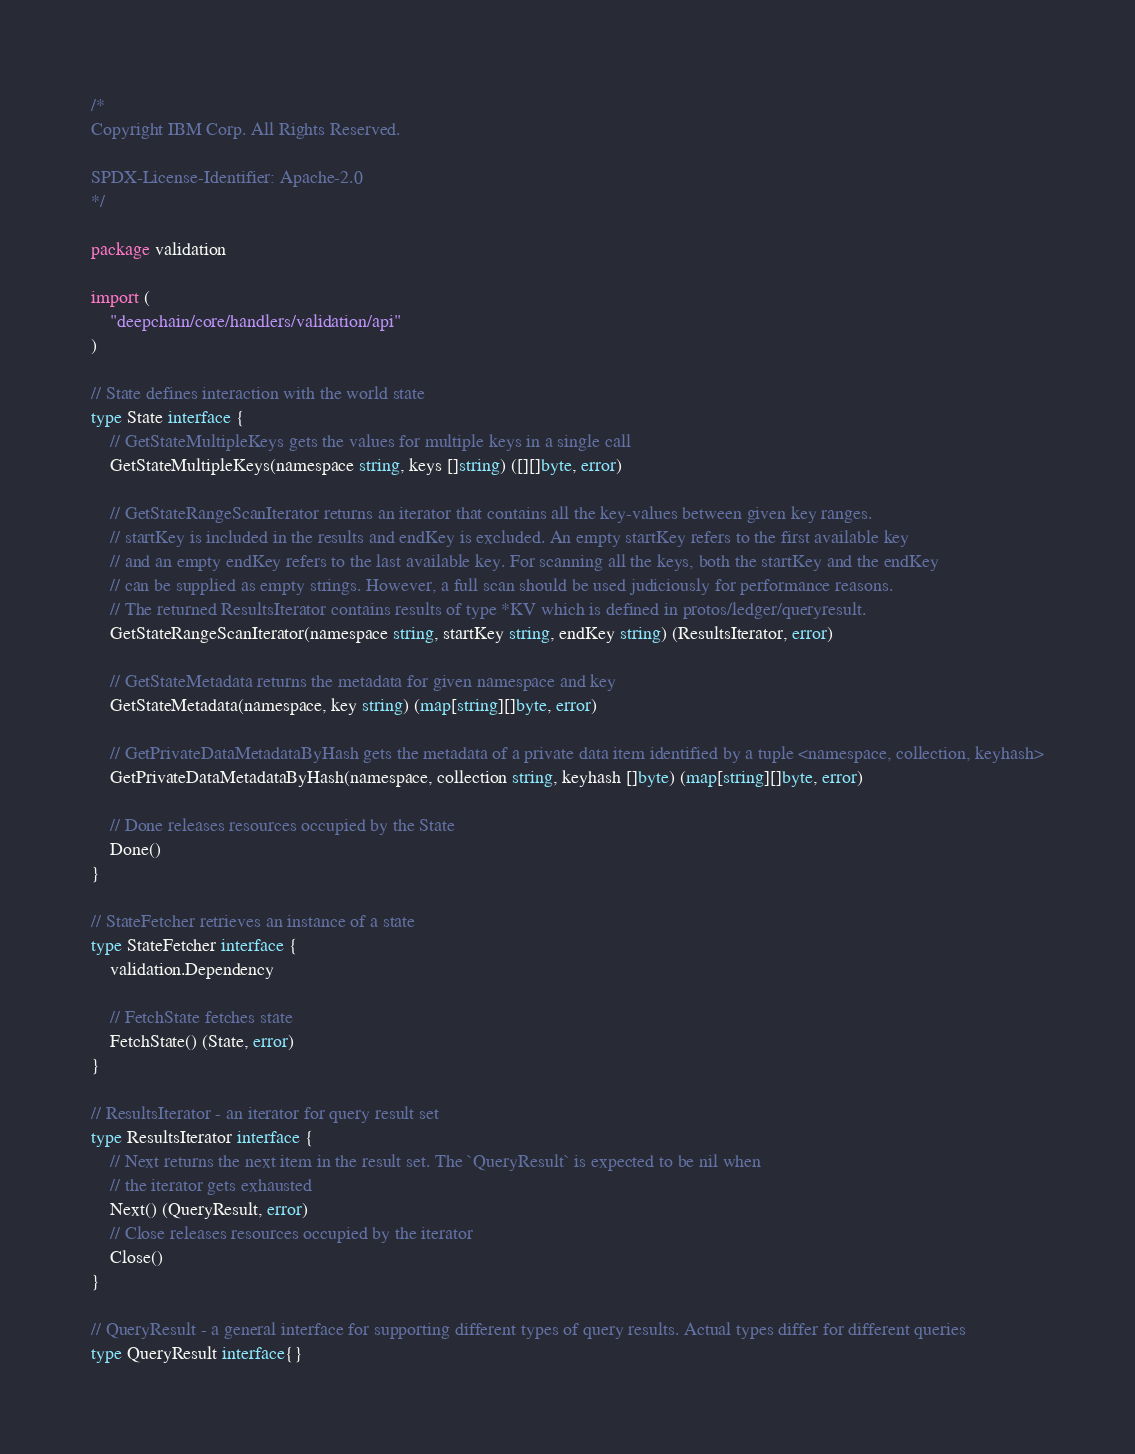Convert code to text. <code><loc_0><loc_0><loc_500><loc_500><_Go_>/*
Copyright IBM Corp. All Rights Reserved.

SPDX-License-Identifier: Apache-2.0
*/

package validation

import (
	"deepchain/core/handlers/validation/api"
)

// State defines interaction with the world state
type State interface {
	// GetStateMultipleKeys gets the values for multiple keys in a single call
	GetStateMultipleKeys(namespace string, keys []string) ([][]byte, error)

	// GetStateRangeScanIterator returns an iterator that contains all the key-values between given key ranges.
	// startKey is included in the results and endKey is excluded. An empty startKey refers to the first available key
	// and an empty endKey refers to the last available key. For scanning all the keys, both the startKey and the endKey
	// can be supplied as empty strings. However, a full scan should be used judiciously for performance reasons.
	// The returned ResultsIterator contains results of type *KV which is defined in protos/ledger/queryresult.
	GetStateRangeScanIterator(namespace string, startKey string, endKey string) (ResultsIterator, error)

	// GetStateMetadata returns the metadata for given namespace and key
	GetStateMetadata(namespace, key string) (map[string][]byte, error)

	// GetPrivateDataMetadataByHash gets the metadata of a private data item identified by a tuple <namespace, collection, keyhash>
	GetPrivateDataMetadataByHash(namespace, collection string, keyhash []byte) (map[string][]byte, error)

	// Done releases resources occupied by the State
	Done()
}

// StateFetcher retrieves an instance of a state
type StateFetcher interface {
	validation.Dependency

	// FetchState fetches state
	FetchState() (State, error)
}

// ResultsIterator - an iterator for query result set
type ResultsIterator interface {
	// Next returns the next item in the result set. The `QueryResult` is expected to be nil when
	// the iterator gets exhausted
	Next() (QueryResult, error)
	// Close releases resources occupied by the iterator
	Close()
}

// QueryResult - a general interface for supporting different types of query results. Actual types differ for different queries
type QueryResult interface{}
</code> 